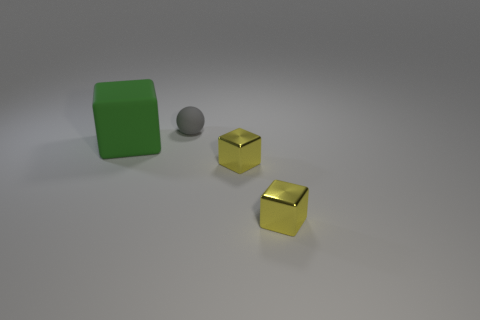How many other things are the same color as the matte cube?
Make the answer very short. 0. How many purple objects are large objects or tiny metallic objects?
Give a very brief answer. 0. How many other objects are the same material as the small sphere?
Your answer should be very brief. 1. There is a block to the left of the rubber thing right of the large matte thing; is there a small metallic thing right of it?
Offer a very short reply. Yes. Are there any other things that have the same shape as the small matte thing?
Offer a very short reply. No. What is the size of the matte thing on the right side of the big rubber object?
Ensure brevity in your answer.  Small. Do the rubber object on the right side of the green matte object and the large green block have the same size?
Your response must be concise. No. There is a rubber object that is in front of the sphere; are there any matte spheres behind it?
Offer a very short reply. Yes. What is the gray sphere made of?
Offer a very short reply. Rubber. There is a large green cube; are there any things right of it?
Offer a terse response. Yes. 